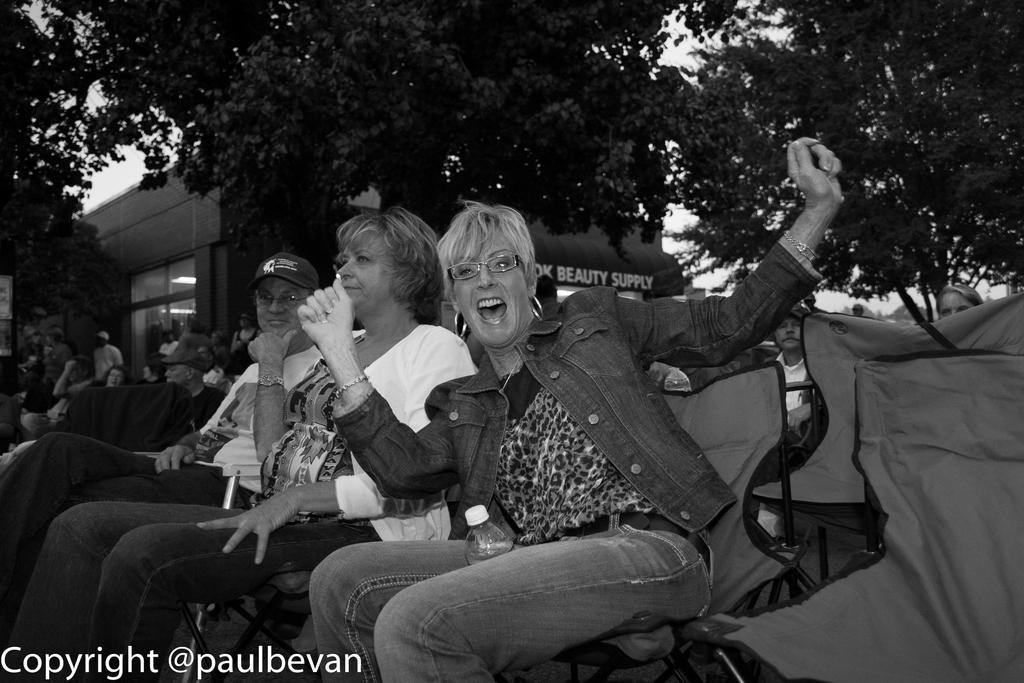Describe this image in one or two sentences. In this picture we can see some people sitting on chairs, in the background there is a building, we can see trees here, at the left bottom there is some text. 